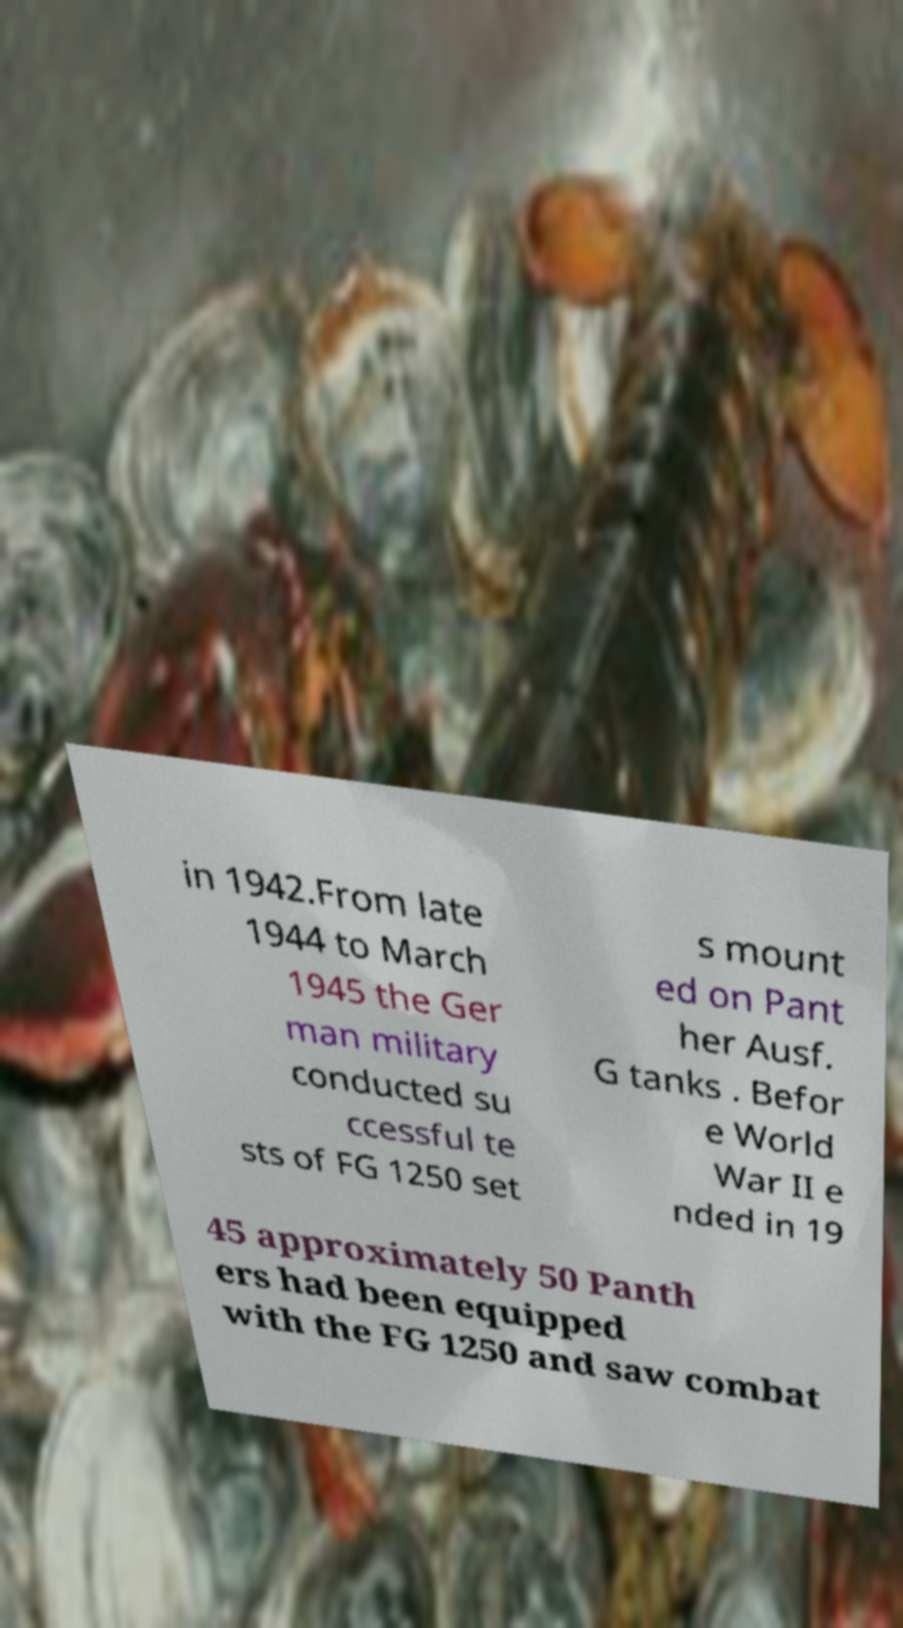I need the written content from this picture converted into text. Can you do that? in 1942.From late 1944 to March 1945 the Ger man military conducted su ccessful te sts of FG 1250 set s mount ed on Pant her Ausf. G tanks . Befor e World War II e nded in 19 45 approximately 50 Panth ers had been equipped with the FG 1250 and saw combat 